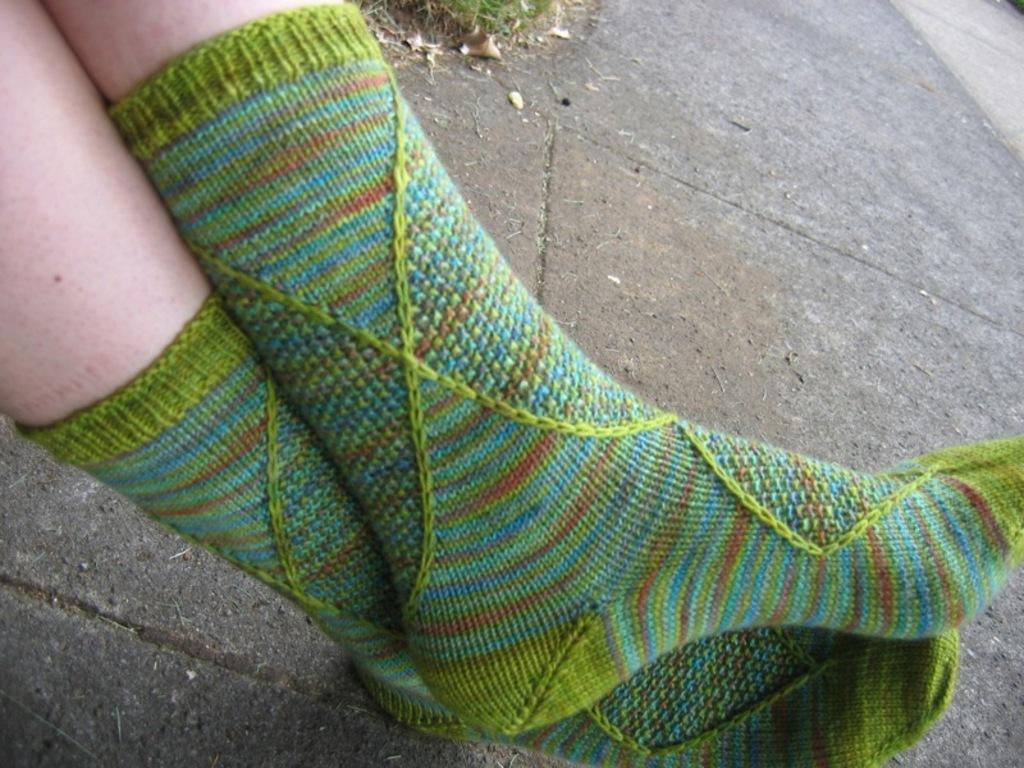What part of a person's body is visible in the image? There are legs of a person visible in the image. What type of clothing is the person wearing on their legs? The person is wearing socks. Where are the legs positioned in the image? The legs are on the ground. What type of pot can be seen in the image? There is no pot present in the image. What type of wool is being used to knit balls in the image? There is no wool or balls present in the image. 